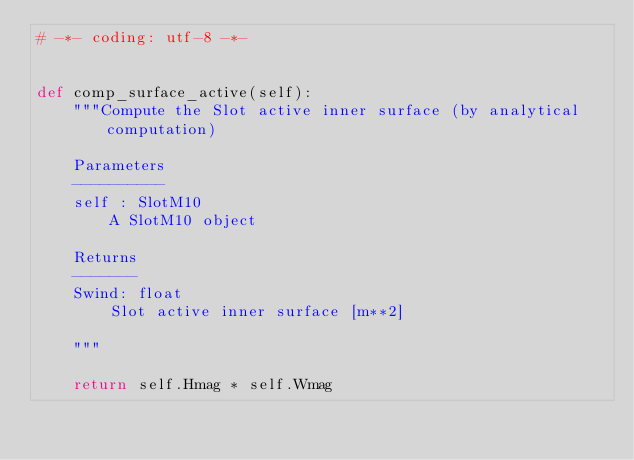<code> <loc_0><loc_0><loc_500><loc_500><_Python_># -*- coding: utf-8 -*-


def comp_surface_active(self):
    """Compute the Slot active inner surface (by analytical computation)

    Parameters
    ----------
    self : SlotM10
        A SlotM10 object

    Returns
    -------
    Swind: float
        Slot active inner surface [m**2]

    """

    return self.Hmag * self.Wmag
</code> 